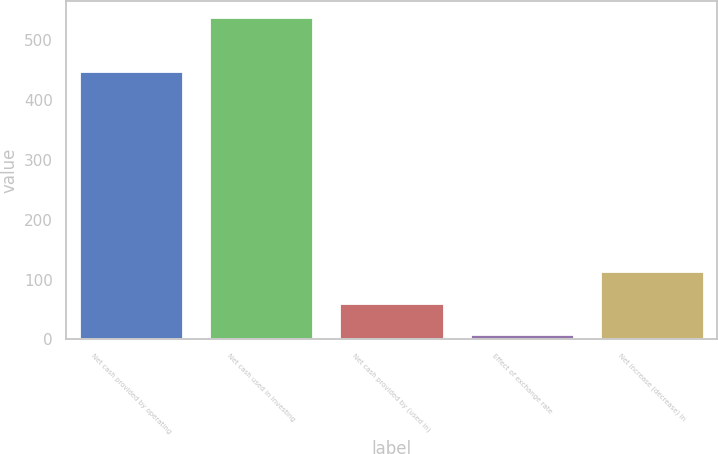Convert chart. <chart><loc_0><loc_0><loc_500><loc_500><bar_chart><fcel>Net cash provided by operating<fcel>Net cash used in investing<fcel>Net cash provided by (used in)<fcel>Effect of exchange rate<fcel>Net increase (decrease) in<nl><fcel>449.1<fcel>539.2<fcel>61.3<fcel>8.2<fcel>114.4<nl></chart> 